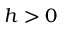Convert formula to latex. <formula><loc_0><loc_0><loc_500><loc_500>h > 0</formula> 